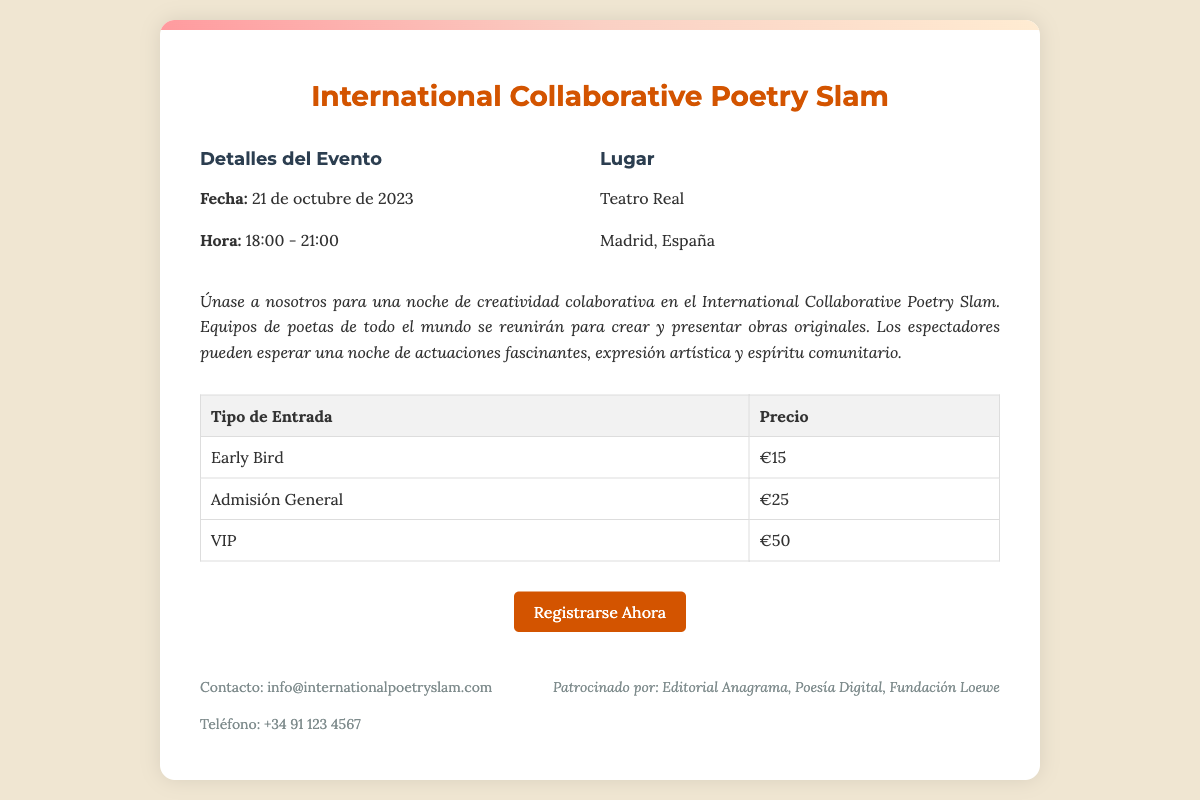¿Cuál es la fecha del evento? La fecha del evento se menciona específicamente en el documento como el día en que tendrá lugar el Poetry Slam.
Answer: 21 de octubre de 2023 ¿A qué hora comienza el evento? La hora de inicio se proporciona en la sección de detalles del evento.
Answer: 18:00 ¿Cuál es el lugar del evento? El lugar del evento se menciona en la sección de información sobre el lugar.
Answer: Teatro Real ¿Cuál es el precio de la entrada VIP? El precio de las entradas se detalla en la tabla de precios del documento.
Answer: €50 ¿Cuántas horas dura el evento? La duración del evento se puede deducir a partir de la hora de inicio y finalización proporcionadas.
Answer: 3 horas ¿Cuál es el patrocinador mencionado en el documento? Un patrocinador se puede encontrar en la parte de pie del documento, que menciona varias entidades.
Answer: Editorial Anagrama ¿Cuál es el tipo de entrada más barato? El tipo de entrada se indica en la tabla de precios y se puede encontrar fácilmente.
Answer: Early Bird ¿Qué estilo de poesía se presentará en el evento? Se puede inferir acerca del estilo de la poesía a partir de la descripción del evento que menciona la creatividad colaborativa.
Answer: Creatividad colaborativa ¿Cuál es el enlace para registrarse? El enlace se proporciona en la sección de registro, donde se invita a participar.
Answer: https://internationalpoetryslam.eventbrite.com 